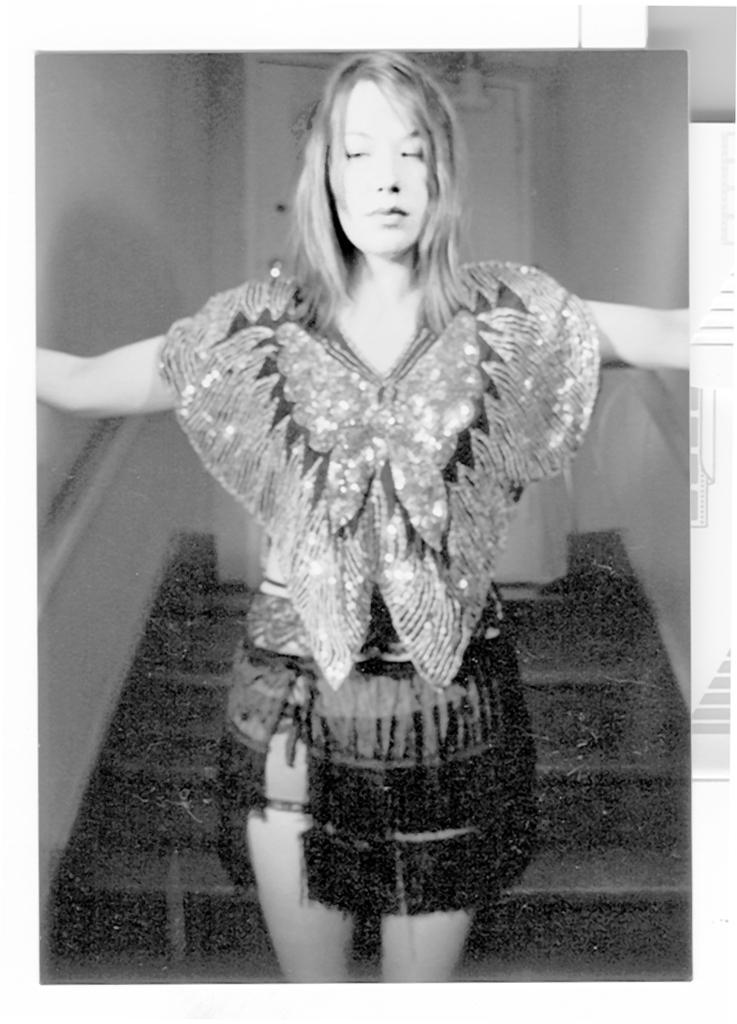Could you give a brief overview of what you see in this image? In this picture there is a woman who is wearing dress. She is standing near to the stairs. On the background we can see door. On the right there is a wall. 